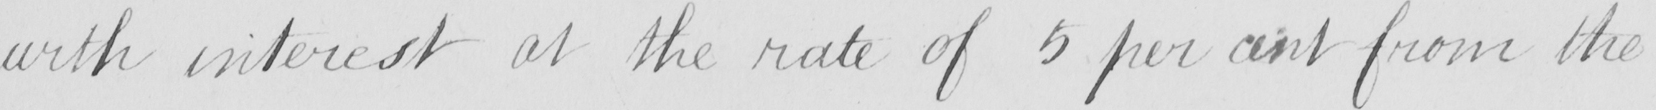What is written in this line of handwriting? with interest at the rate of 5 per cent from the 